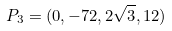<formula> <loc_0><loc_0><loc_500><loc_500>P _ { 3 } = ( 0 , - 7 2 , 2 \sqrt { 3 } , 1 2 )</formula> 